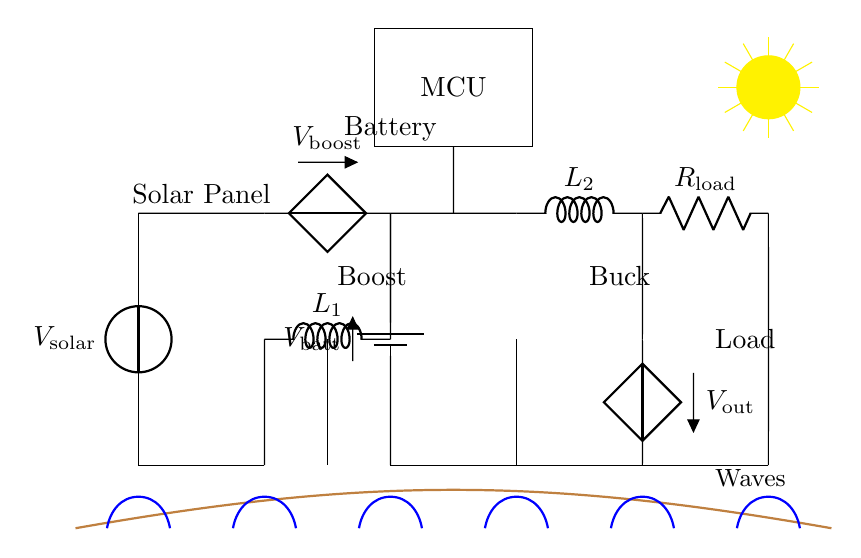What type of power source is used in this circuit? The circuit uses a solar panel as a power source, which is represented by the voltage source labeled V solar.
Answer: Solar panel What is the role of the boost converter in the circuit? The boost converter increases the voltage from the solar panel to a higher level required to charge the battery, demonstrated by the voltage label V boost at its output.
Answer: Increase voltage How many types of converters are in the circuit? There are two types of converters in the circuit: a boost converter and a buck converter, clearly labeled in the circuit diagram.
Answer: Two What is the voltage supplied to the load? The voltage supplied to the load is represented by the label V out, which is placed at the output of the buck converter that steps down the voltage for the load.
Answer: V out What is the purpose of the battery in this circuit? The battery stores the energy gathered from the solar panel and supplies it to the buck converter when needed to power the load, as shown by the battery symbol labeled V batt in the diagram.
Answer: Energy storage Which component is used to control the entire circuit? The component used to control the circuit is the microcontroller, indicated by the rectangle labeled MCU at the top of the diagram.
Answer: Microcontroller 